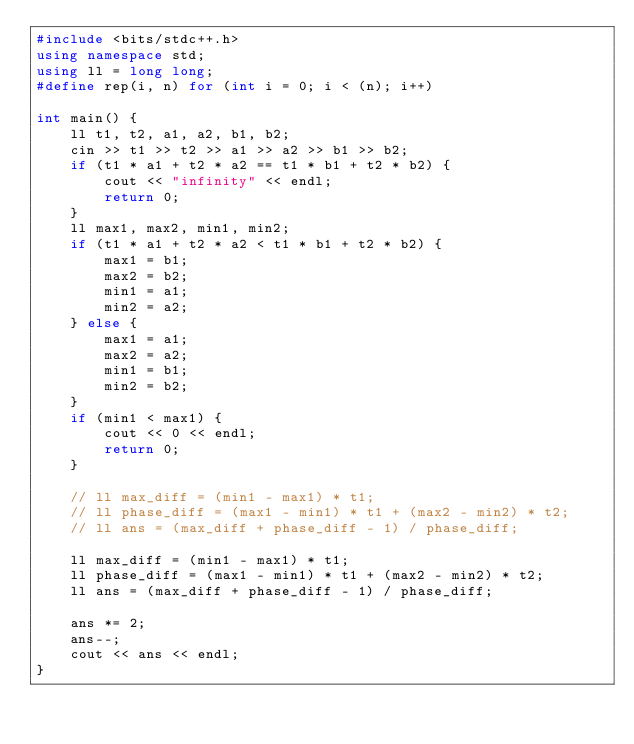<code> <loc_0><loc_0><loc_500><loc_500><_C++_>#include <bits/stdc++.h>
using namespace std;
using ll = long long;
#define rep(i, n) for (int i = 0; i < (n); i++)

int main() {
    ll t1, t2, a1, a2, b1, b2;
    cin >> t1 >> t2 >> a1 >> a2 >> b1 >> b2;
    if (t1 * a1 + t2 * a2 == t1 * b1 + t2 * b2) {
        cout << "infinity" << endl;
        return 0;
    }
    ll max1, max2, min1, min2;
    if (t1 * a1 + t2 * a2 < t1 * b1 + t2 * b2) {
        max1 = b1;
        max2 = b2;
        min1 = a1;
        min2 = a2;
    } else {
        max1 = a1;
        max2 = a2;
        min1 = b1;
        min2 = b2;
    }
    if (min1 < max1) {
        cout << 0 << endl;
        return 0;
    }
    
    // ll max_diff = (min1 - max1) * t1;
    // ll phase_diff = (max1 - min1) * t1 + (max2 - min2) * t2;
    // ll ans = (max_diff + phase_diff - 1) / phase_diff;
    
    ll max_diff = (min1 - max1) * t1;
    ll phase_diff = (max1 - min1) * t1 + (max2 - min2) * t2;
    ll ans = (max_diff + phase_diff - 1) / phase_diff;
    
    ans *= 2;
    ans--;
    cout << ans << endl;
}</code> 